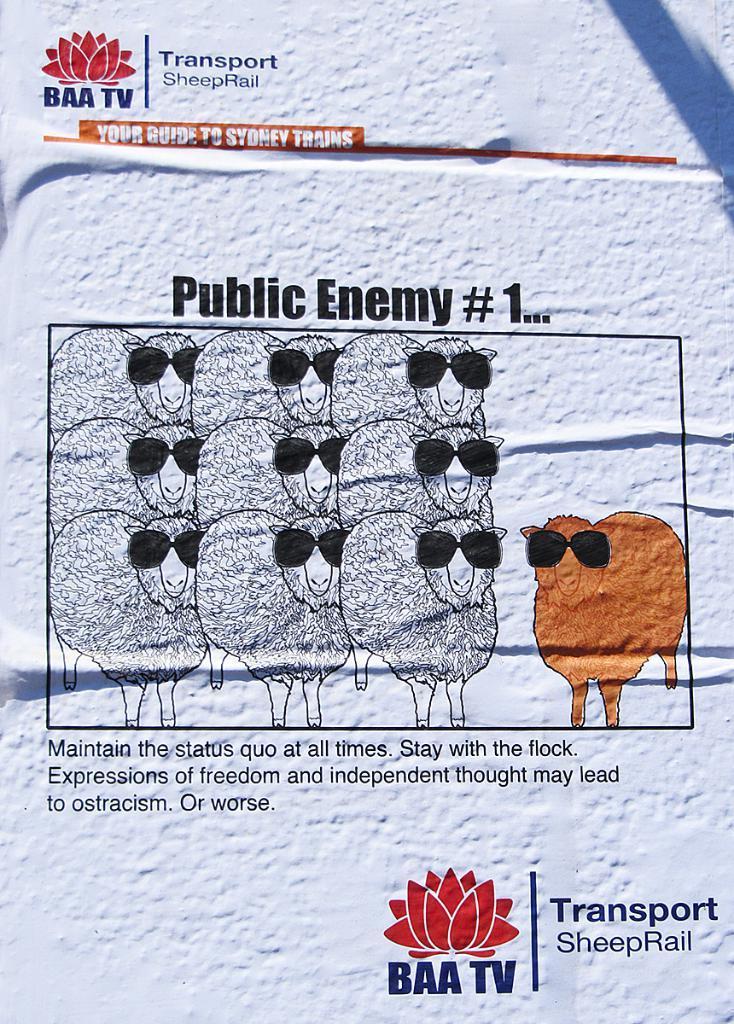Describe this image in one or two sentences. In this image there is a poster on the wall. There are a few images of sheeps and there is a text on the poster. 